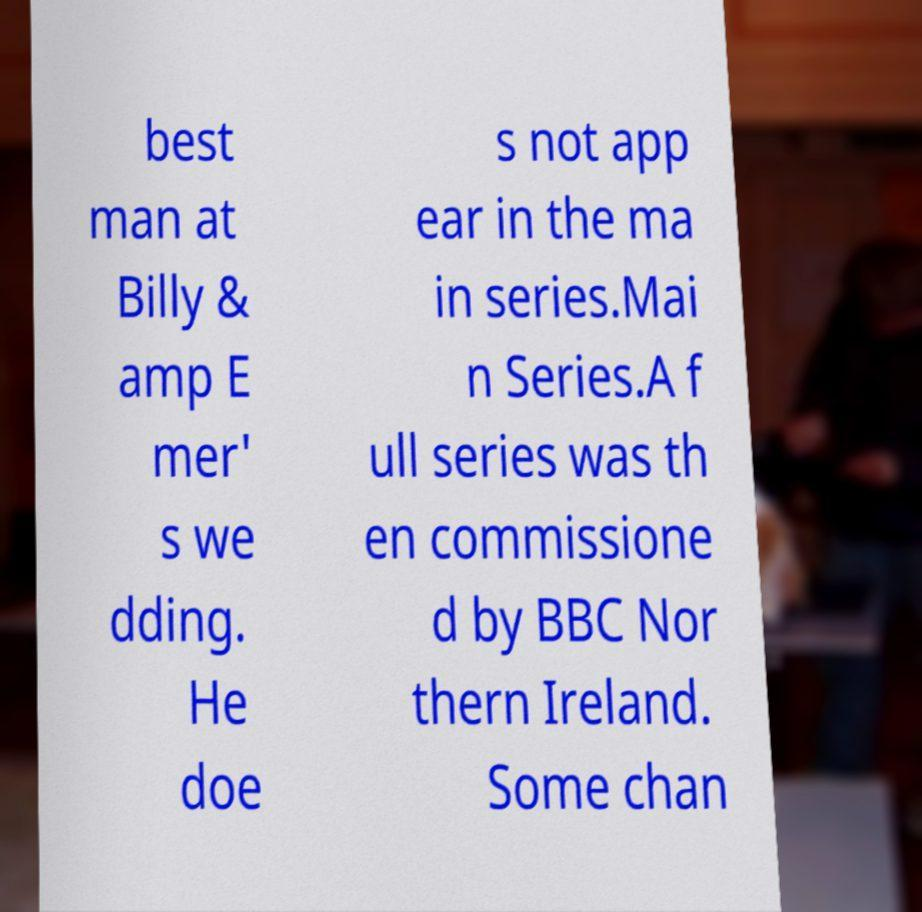Could you extract and type out the text from this image? best man at Billy & amp E mer' s we dding. He doe s not app ear in the ma in series.Mai n Series.A f ull series was th en commissione d by BBC Nor thern Ireland. Some chan 